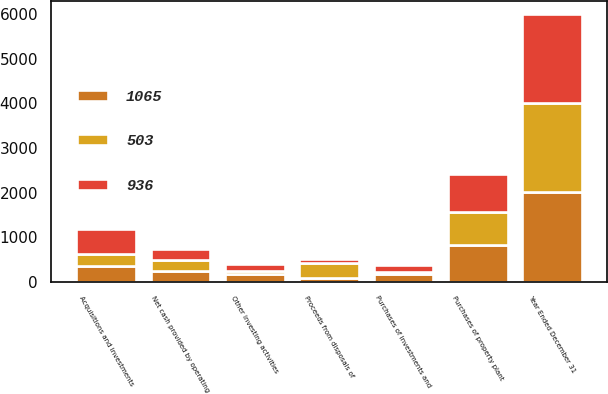<chart> <loc_0><loc_0><loc_500><loc_500><stacked_bar_chart><ecel><fcel>Year Ended December 31<fcel>Net cash provided by operating<fcel>Acquisitions and investments<fcel>Purchases of investments and<fcel>Proceeds from disposals of<fcel>Purchases of property plant<fcel>Other investing activities<nl><fcel>503<fcel>2004<fcel>243<fcel>267<fcel>46<fcel>341<fcel>755<fcel>63<nl><fcel>1065<fcel>2003<fcel>243<fcel>359<fcel>177<fcel>87<fcel>812<fcel>178<nl><fcel>936<fcel>2002<fcel>243<fcel>544<fcel>141<fcel>69<fcel>851<fcel>159<nl></chart> 